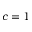Convert formula to latex. <formula><loc_0><loc_0><loc_500><loc_500>c = 1</formula> 